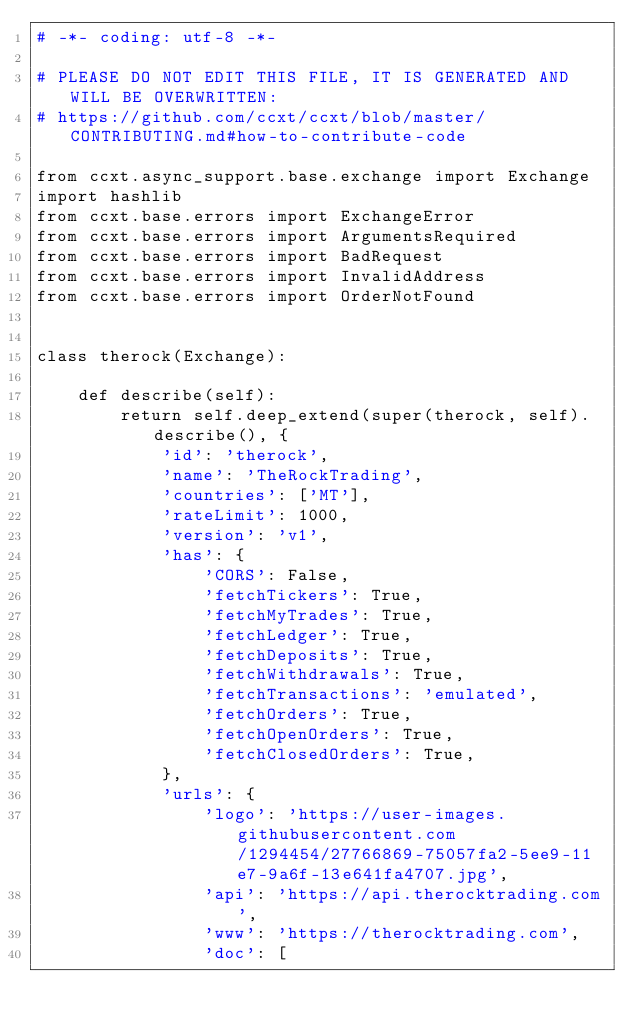Convert code to text. <code><loc_0><loc_0><loc_500><loc_500><_Python_># -*- coding: utf-8 -*-

# PLEASE DO NOT EDIT THIS FILE, IT IS GENERATED AND WILL BE OVERWRITTEN:
# https://github.com/ccxt/ccxt/blob/master/CONTRIBUTING.md#how-to-contribute-code

from ccxt.async_support.base.exchange import Exchange
import hashlib
from ccxt.base.errors import ExchangeError
from ccxt.base.errors import ArgumentsRequired
from ccxt.base.errors import BadRequest
from ccxt.base.errors import InvalidAddress
from ccxt.base.errors import OrderNotFound


class therock(Exchange):

    def describe(self):
        return self.deep_extend(super(therock, self).describe(), {
            'id': 'therock',
            'name': 'TheRockTrading',
            'countries': ['MT'],
            'rateLimit': 1000,
            'version': 'v1',
            'has': {
                'CORS': False,
                'fetchTickers': True,
                'fetchMyTrades': True,
                'fetchLedger': True,
                'fetchDeposits': True,
                'fetchWithdrawals': True,
                'fetchTransactions': 'emulated',
                'fetchOrders': True,
                'fetchOpenOrders': True,
                'fetchClosedOrders': True,
            },
            'urls': {
                'logo': 'https://user-images.githubusercontent.com/1294454/27766869-75057fa2-5ee9-11e7-9a6f-13e641fa4707.jpg',
                'api': 'https://api.therocktrading.com',
                'www': 'https://therocktrading.com',
                'doc': [</code> 